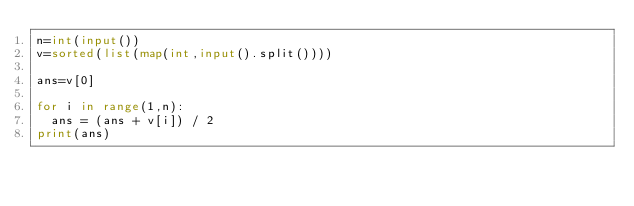Convert code to text. <code><loc_0><loc_0><loc_500><loc_500><_Python_>n=int(input())
v=sorted(list(map(int,input().split())))

ans=v[0]

for i in range(1,n):
  ans = (ans + v[i]) / 2
print(ans)  </code> 